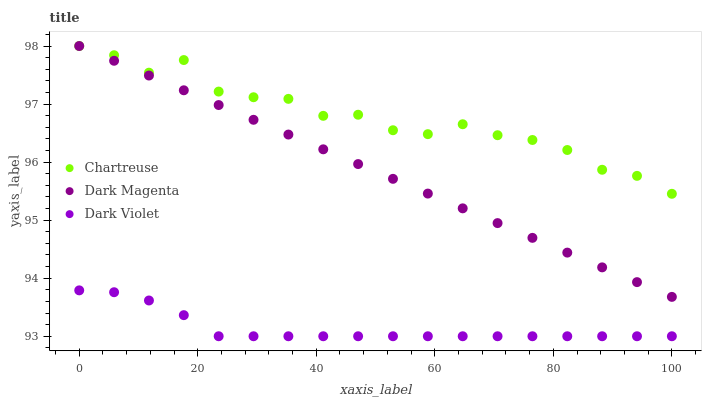Does Dark Violet have the minimum area under the curve?
Answer yes or no. Yes. Does Chartreuse have the maximum area under the curve?
Answer yes or no. Yes. Does Dark Magenta have the minimum area under the curve?
Answer yes or no. No. Does Dark Magenta have the maximum area under the curve?
Answer yes or no. No. Is Dark Magenta the smoothest?
Answer yes or no. Yes. Is Chartreuse the roughest?
Answer yes or no. Yes. Is Dark Violet the smoothest?
Answer yes or no. No. Is Dark Violet the roughest?
Answer yes or no. No. Does Dark Violet have the lowest value?
Answer yes or no. Yes. Does Dark Magenta have the lowest value?
Answer yes or no. No. Does Dark Magenta have the highest value?
Answer yes or no. Yes. Does Dark Violet have the highest value?
Answer yes or no. No. Is Dark Violet less than Chartreuse?
Answer yes or no. Yes. Is Chartreuse greater than Dark Violet?
Answer yes or no. Yes. Does Chartreuse intersect Dark Magenta?
Answer yes or no. Yes. Is Chartreuse less than Dark Magenta?
Answer yes or no. No. Is Chartreuse greater than Dark Magenta?
Answer yes or no. No. Does Dark Violet intersect Chartreuse?
Answer yes or no. No. 